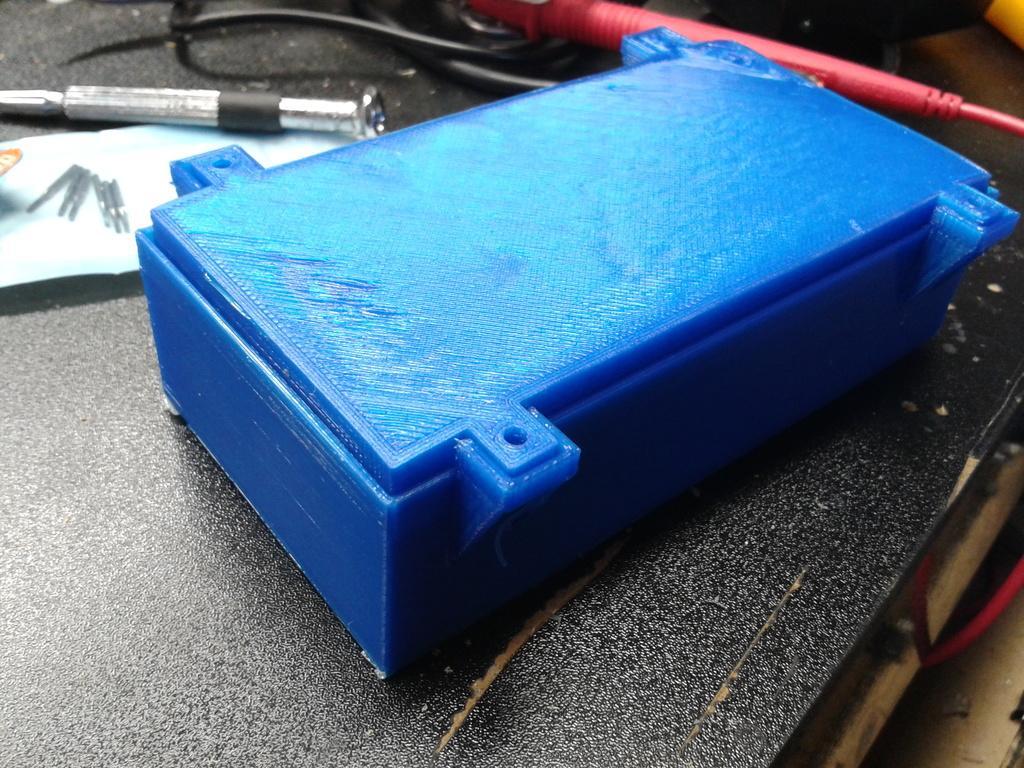Please provide a concise description of this image. In the center of the image, we can see a blue color box and there are needles on the paper and we can see some objects and some wires on the table. 